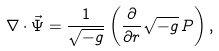<formula> <loc_0><loc_0><loc_500><loc_500>\nabla \cdot \vec { \Psi } = \frac { 1 } { \sqrt { - g } } \left ( \frac { \partial } { \partial r } \sqrt { - g } \, P \right ) ,</formula> 